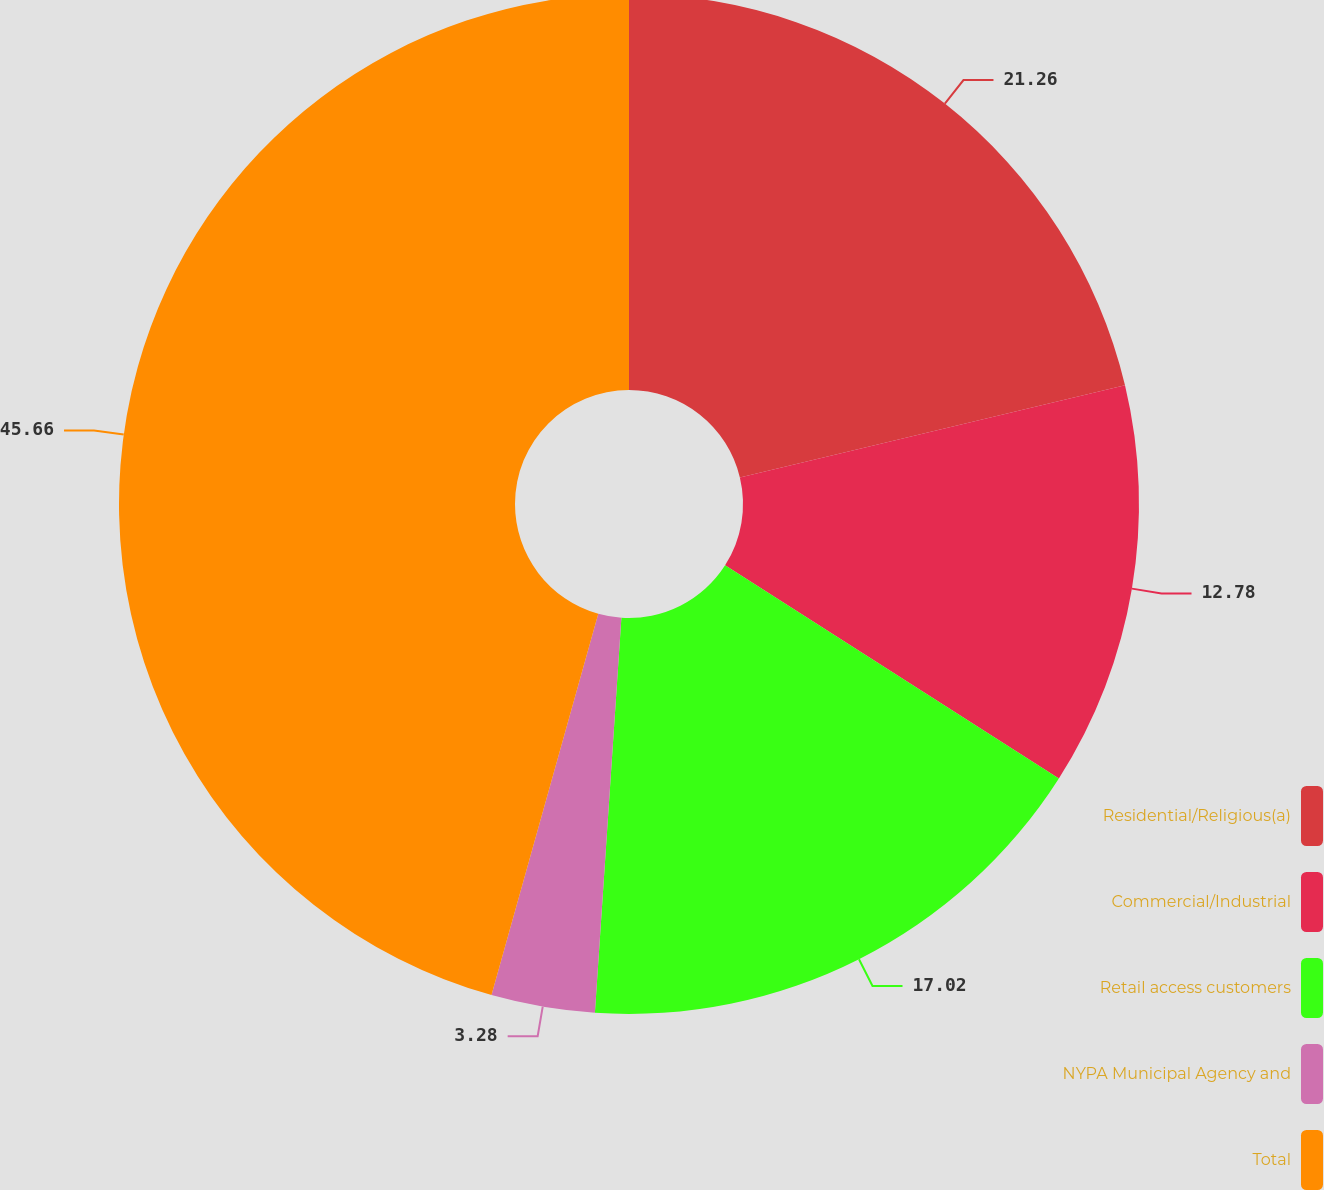Convert chart. <chart><loc_0><loc_0><loc_500><loc_500><pie_chart><fcel>Residential/Religious(a)<fcel>Commercial/Industrial<fcel>Retail access customers<fcel>NYPA Municipal Agency and<fcel>Total<nl><fcel>21.26%<fcel>12.78%<fcel>17.02%<fcel>3.28%<fcel>45.65%<nl></chart> 